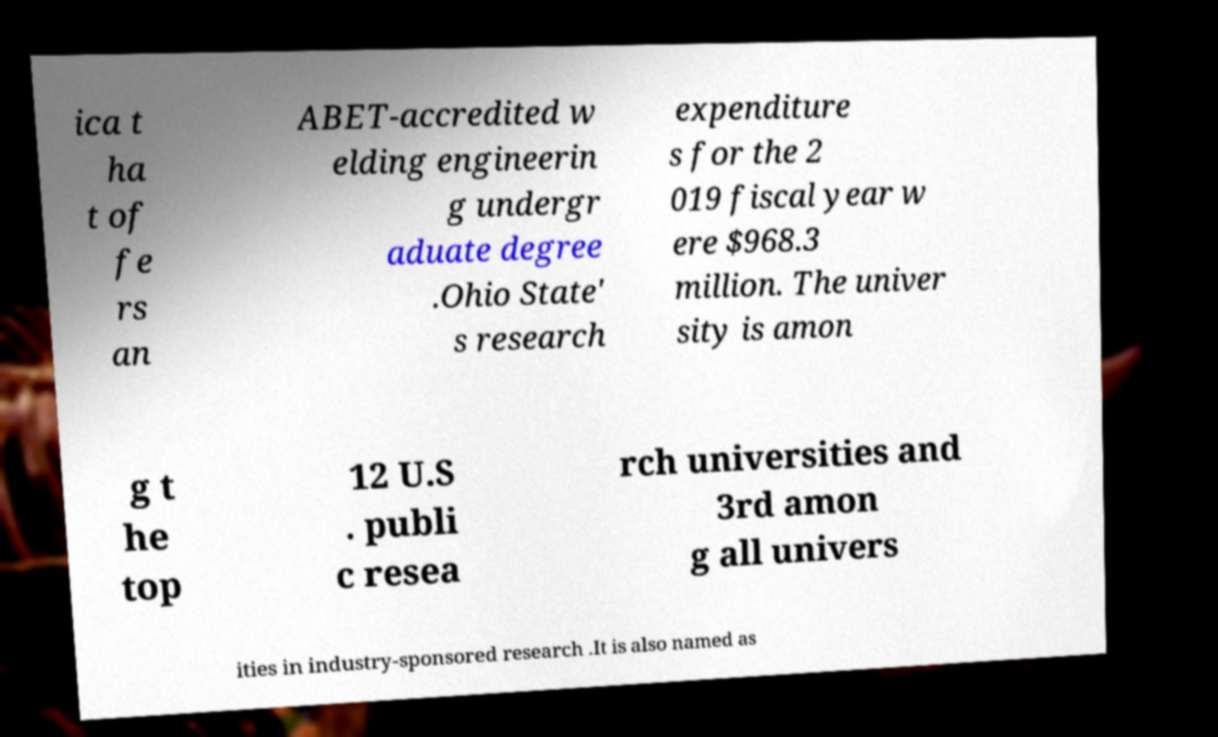There's text embedded in this image that I need extracted. Can you transcribe it verbatim? ica t ha t of fe rs an ABET-accredited w elding engineerin g undergr aduate degree .Ohio State' s research expenditure s for the 2 019 fiscal year w ere $968.3 million. The univer sity is amon g t he top 12 U.S . publi c resea rch universities and 3rd amon g all univers ities in industry-sponsored research .It is also named as 